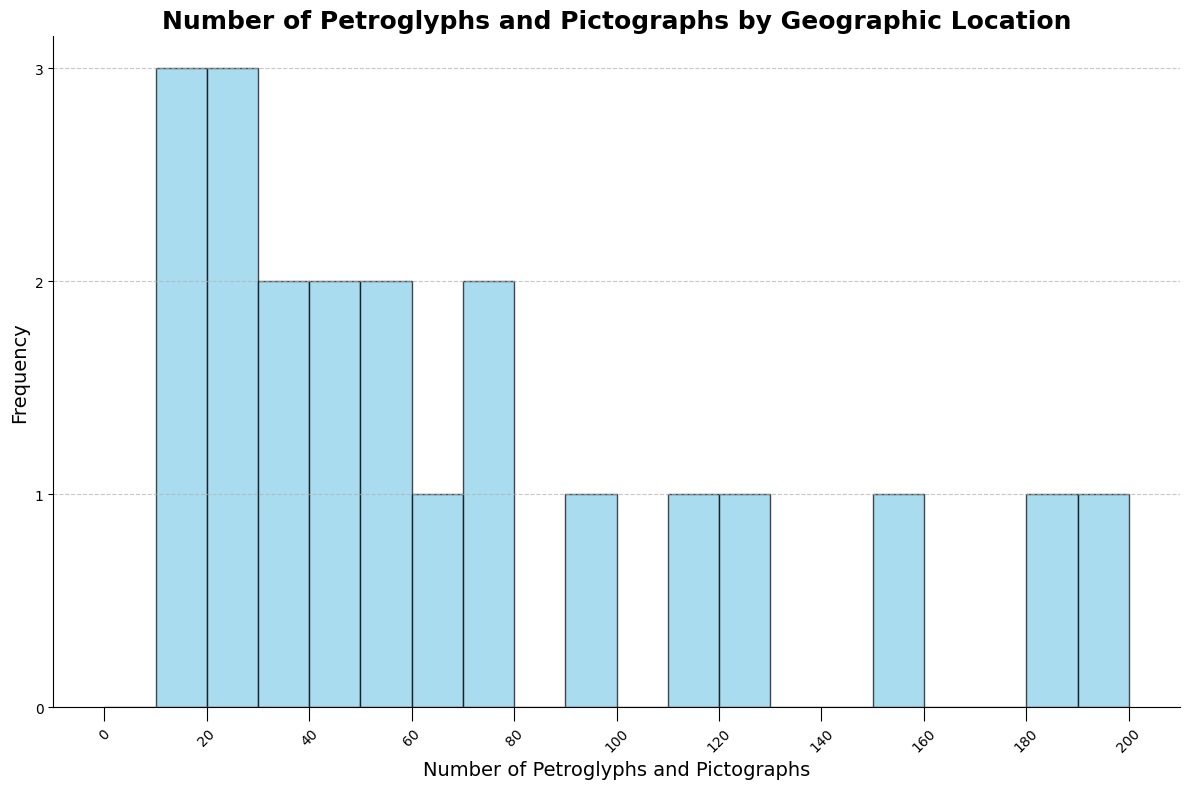What's the range of the number of petroglyphs and pictographs found across locations? To find the range, subtract the minimum count from the maximum count. From the data, the minimum is 10 (Maine) and the maximum is 200 (New Mexico). Thus, the range is 200 - 10 = 190.
Answer: 190 Which location has the highest frequency of petroglyphs and pictographs? By referencing the histogram, identify the tallest bar. The tallest bar represents 200 petroglyphs and pictographs, which corresponds to New Mexico.
Answer: New Mexico Compare the number of petroglyphs and pictographs found in Texas and Arizona. Which location has more? From the data, Texas has 180 and Arizona has 150 petroglyphs and pictographs. Therefore, Texas has more.
Answer: Texas What is the median number of petroglyphs and pictographs found in the locations? To find the median, arrange the counts in ascending order and identify the middle value. In this case, the counts (sorted) are [10, 15, 18, 20, 22, 25, 30, 35, 40, 45, 50, 55, 60, 70, 75, 90, 110, 120, 150, 180, 200]. The median is the 11th value in this sorted list, which is 50.
Answer: 50 How many locations have petroglyphs and pictographs counts between 50 and 100? Identify the bars that fall within the range of 50 to 100. There are counts of 55, 60, 70, 75, and 90, which correspond to Washington, Oregon, Alaska, Nevada, and California.
Answer: 5 Which geographic location has the least number of petroglyphs and pictographs? The shortest bar in the histogram represents the least number, which is 10 (Maine).
Answer: Maine Are there more locations with fewer than 50 petroglyphs and pictographs or with more than 150? From the data, the counts fewer than 50 are 10, 15, 18, 20, 22, 25, 30, 35, 40, and 45, making 10 locations. The counts more than 150 are 150, 180, and 200, making 3 locations. Thus, there are more locations with fewer than 50 petroglyphs and pictographs.
Answer: Fewer than 50 What proportion of locations found have more than 100 petroglyphs and pictographs? First, count the locations with counts above 100: 110, 120, 150, 180, and 200, which are 5 out of 21 locations. Thus, the proportion is 5/21.
Answer: 5/21 How many locations have exactly 50 petroglyphs and pictographs? By examining the histogram, identify any bars representing the count of 50. Only Wyoming fits this category.
Answer: 1 What is the sum of petroglyphs and pictographs found in Oregon and Washington? From the data, Oregon has 60 and Washington has 55 petroglyphs and pictographs. Adding them yields 60 + 55 = 115.
Answer: 115 